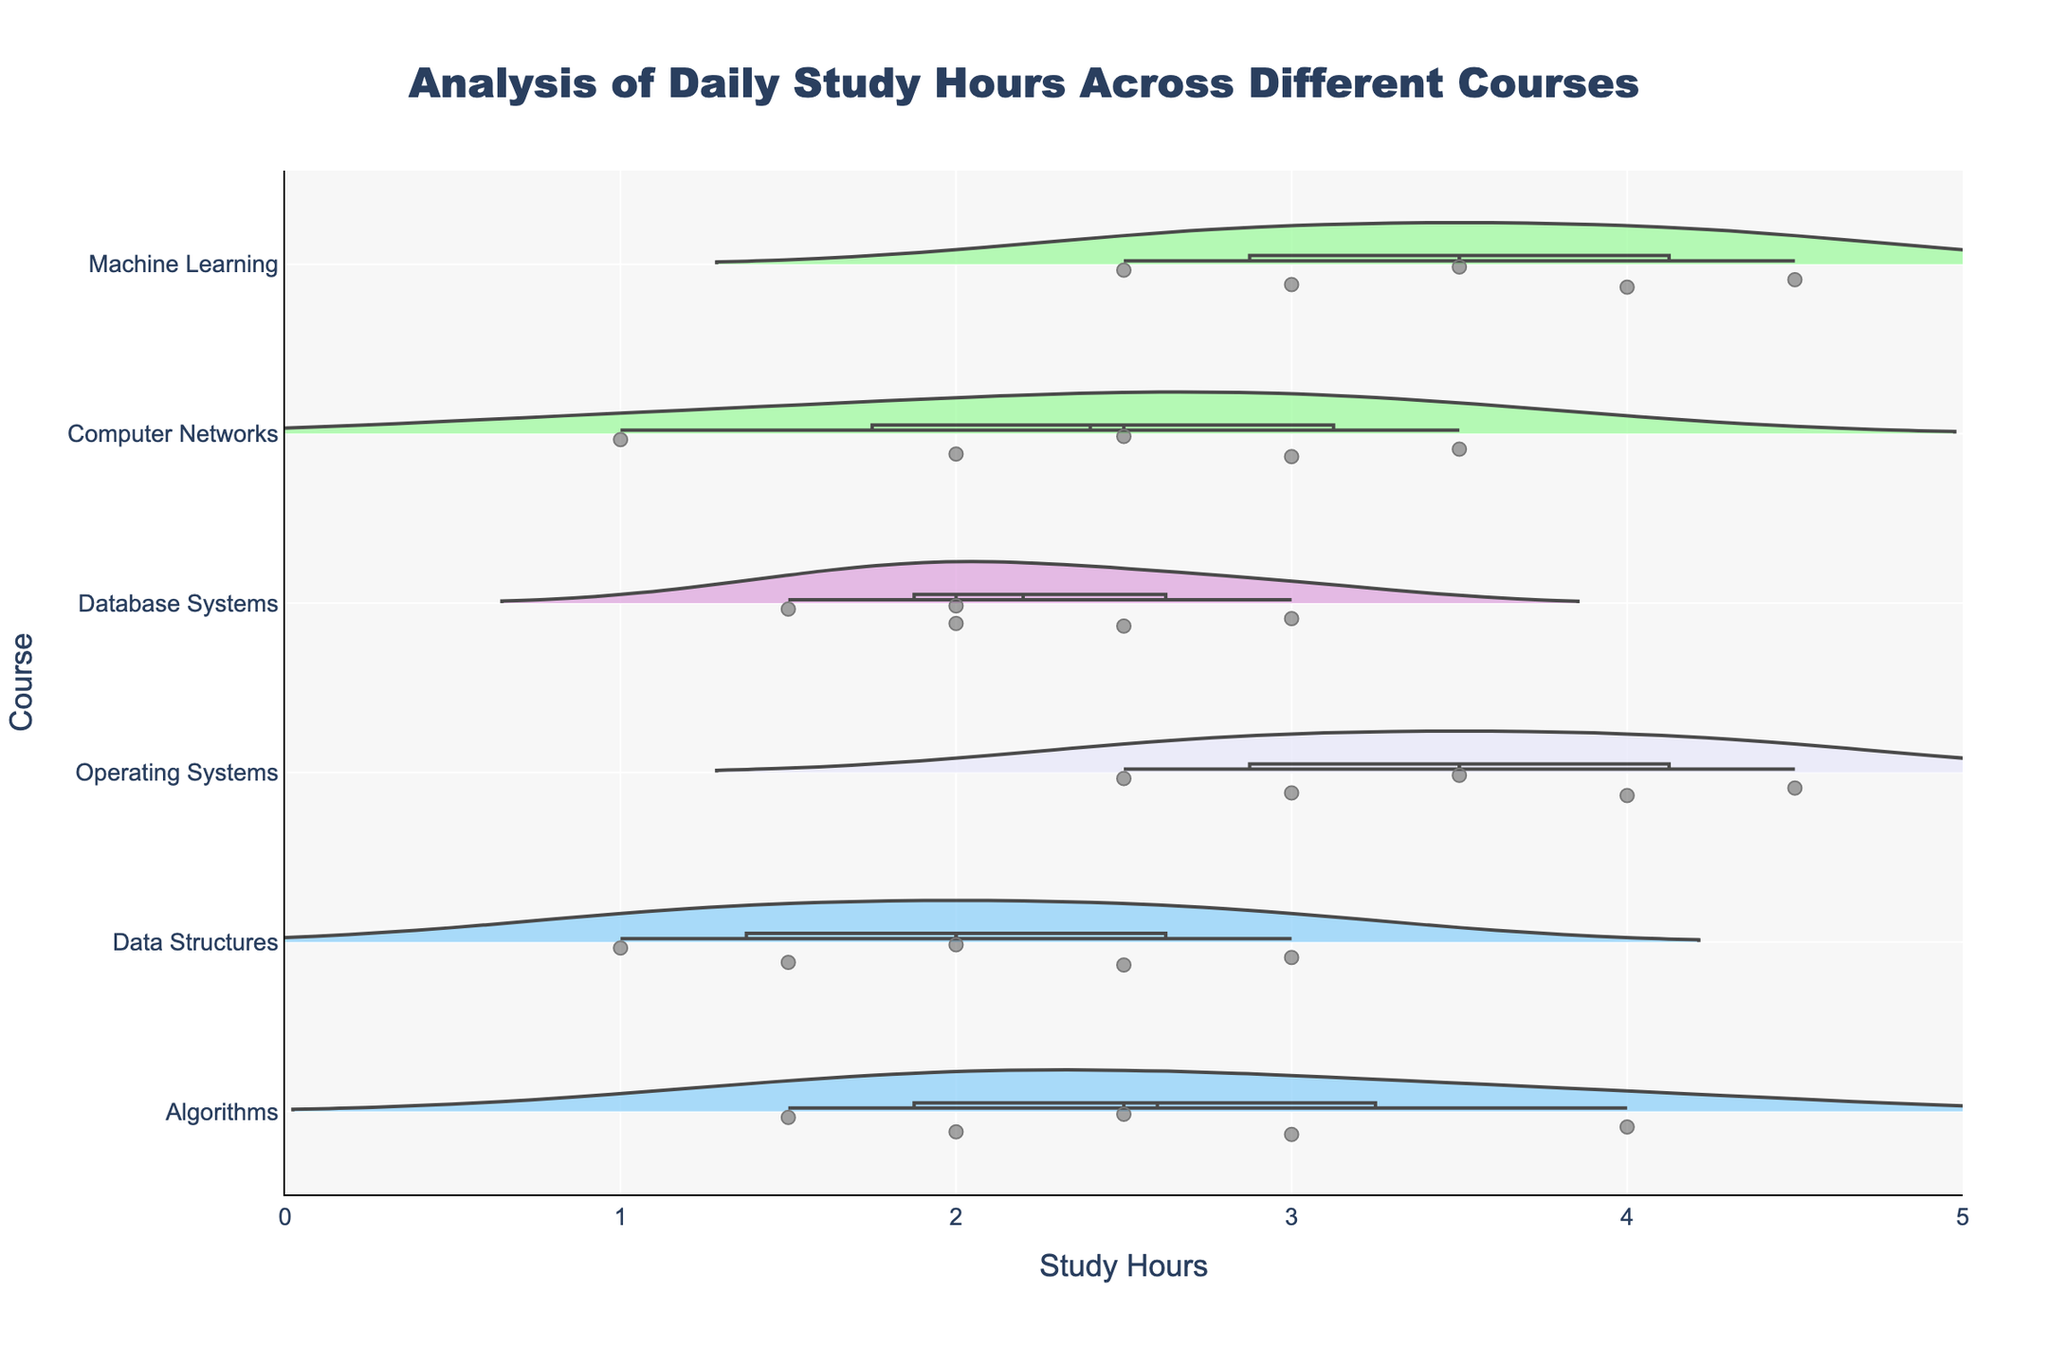How many data points are there for the 'Algorithms' course? There are five separate violin plots, each representing a different course, within the horizontal violin chart. To determine the number of data points for 'Algorithms,' one needs to count the individual points presented in the 'Algorithms' violin plot.
Answer: 5 What's the mean value of the 'Machine Learning' study hours? The plot includes a mean line for each course's violin plot, which can be used to identify the average study hours. For 'Machine Learning,' the mean value line indicates approximately 3.5 hours.
Answer: 3.5 Which course has the highest median study hours? To determine the course with the highest median study hours, observe the lines displayed within the violin plots marking the median values. 'Machine Learning' has the highest median value among the courses.
Answer: Machine Learning Is the distribution of study hours more varied for 'Operating Systems' or 'Computer Networks'? To compare the variations in study hours, observe the spread and width of the violin plots. 'Operating Systems' exhibits a wider and more varied distribution compared to 'Computer Networks,' suggesting greater variance.
Answer: Operating Systems What are the minimum and maximum study hours recorded for 'Data Structures'? To find the minimum and maximum study hours for 'Data Structures,' examine the range of the violin plot's kernel density estimate. 'Data Structures' ranges from 1.0 to 3.0 hours.
Answer: 1.0 to 3.0 Which courses have outliers in their data distributions? Look for distinct points that lie outside the primary range of the violin plots, as these signify outliers. 'Machine Learning' and 'Operating Systems' exhibit outliers.
Answer: Machine Learning, Operating Systems What can be inferred about the central tendency of study hours for 'Database Systems' relative to other courses? Examine the position of the median line within the 'Database Systems' violin plot compared to others. The study hours' central tendency for 'Database Systems' is neither particularly high nor low, falling around the middle of the range.
Answer: Median study hours are moderate How do study hours for 'Computer Networks' compare to 'Algorithms' in terms of distribution shape? Analyze the shape and spread of the violin plots for 'Computer Networks' and 'Algorithms.' 'Computer Networks' has a less varied and more symmetric distribution compared to the extended and slightly skewed distribution of 'Algorithms.'
Answer: Computer Networks is less varied and more symmetric Which course appears to have the most consistent study hours among students? Identify the course with the narrowest violin plot, indicating a small range and less variability in study hours. 'Data Structures' displays the most consistent study hours distribution-wise.
Answer: Data Structures 